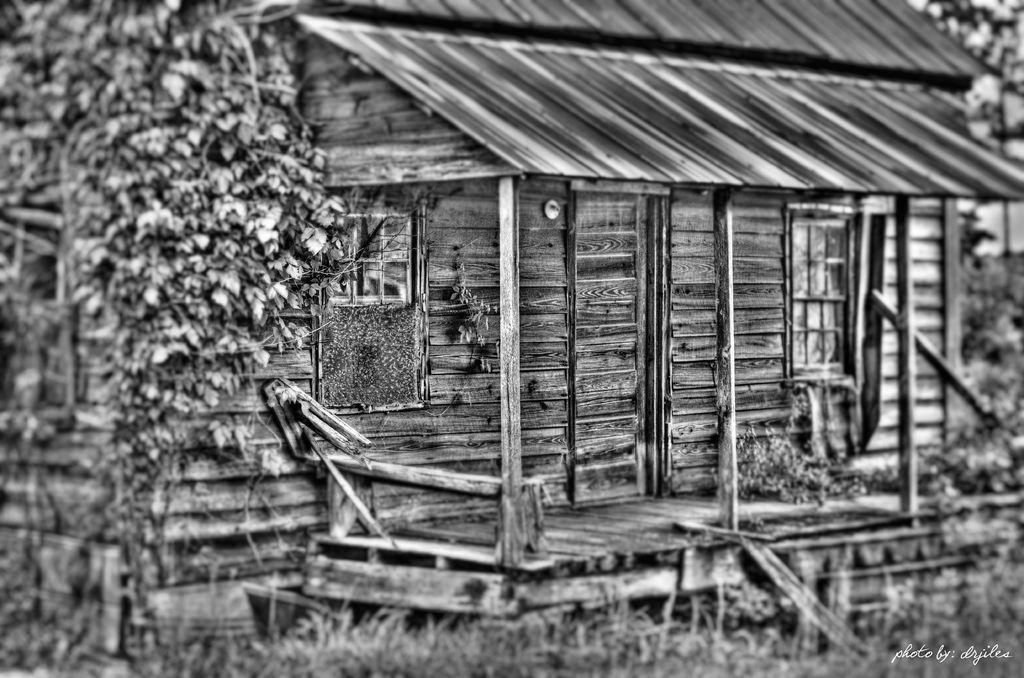What type of house is in the image? There is a wooden house in the image. What architectural feature is present in the image? There are stairs in the image. What type of vegetation is in the image? There is grass in the image. What natural element is in the image? There is a tree in the image. What part of the house is visible in the image? There is a window in the image. What type of steel structure can be seen in the image? There is no steel structure present in the image. What event related to death is depicted in the image? There is no event related to death depicted in the image. 